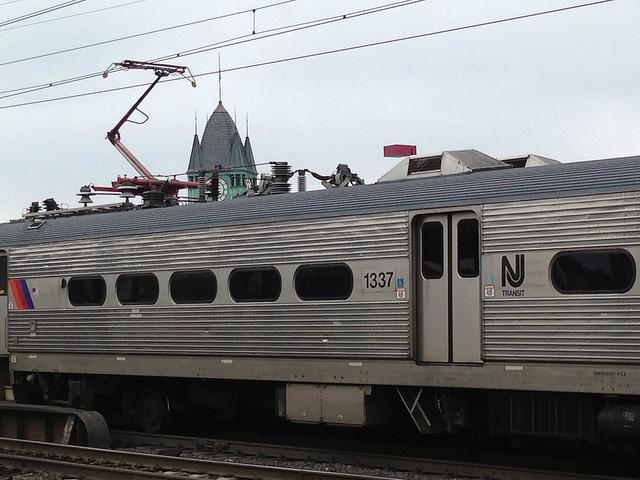How many train windows are visible?
Give a very brief answer. 8. How many men are wearing sunglasses?
Give a very brief answer. 0. 